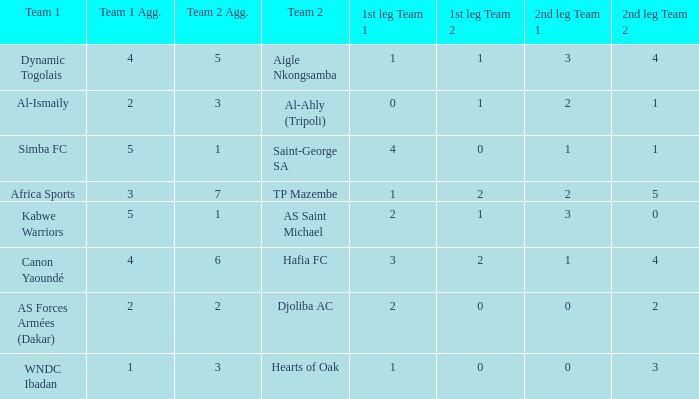What was the 2nd leg result in the match that scored a 2-0 in the 1st leg? 0-2 1. 